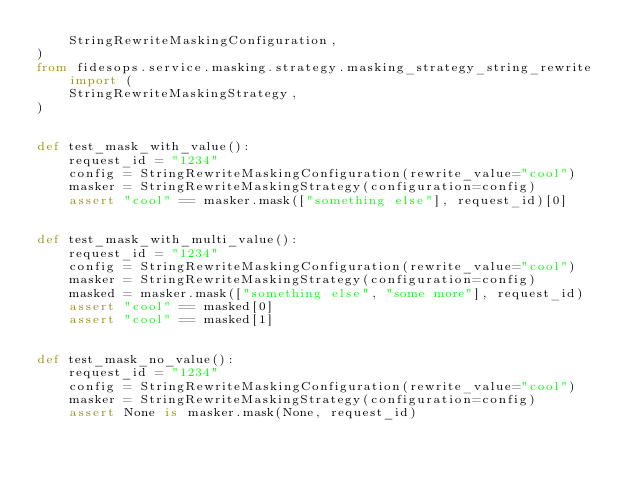<code> <loc_0><loc_0><loc_500><loc_500><_Python_>    StringRewriteMaskingConfiguration,
)
from fidesops.service.masking.strategy.masking_strategy_string_rewrite import (
    StringRewriteMaskingStrategy,
)


def test_mask_with_value():
    request_id = "1234"
    config = StringRewriteMaskingConfiguration(rewrite_value="cool")
    masker = StringRewriteMaskingStrategy(configuration=config)
    assert "cool" == masker.mask(["something else"], request_id)[0]


def test_mask_with_multi_value():
    request_id = "1234"
    config = StringRewriteMaskingConfiguration(rewrite_value="cool")
    masker = StringRewriteMaskingStrategy(configuration=config)
    masked = masker.mask(["something else", "some more"], request_id)
    assert "cool" == masked[0]
    assert "cool" == masked[1]


def test_mask_no_value():
    request_id = "1234"
    config = StringRewriteMaskingConfiguration(rewrite_value="cool")
    masker = StringRewriteMaskingStrategy(configuration=config)
    assert None is masker.mask(None, request_id)
</code> 